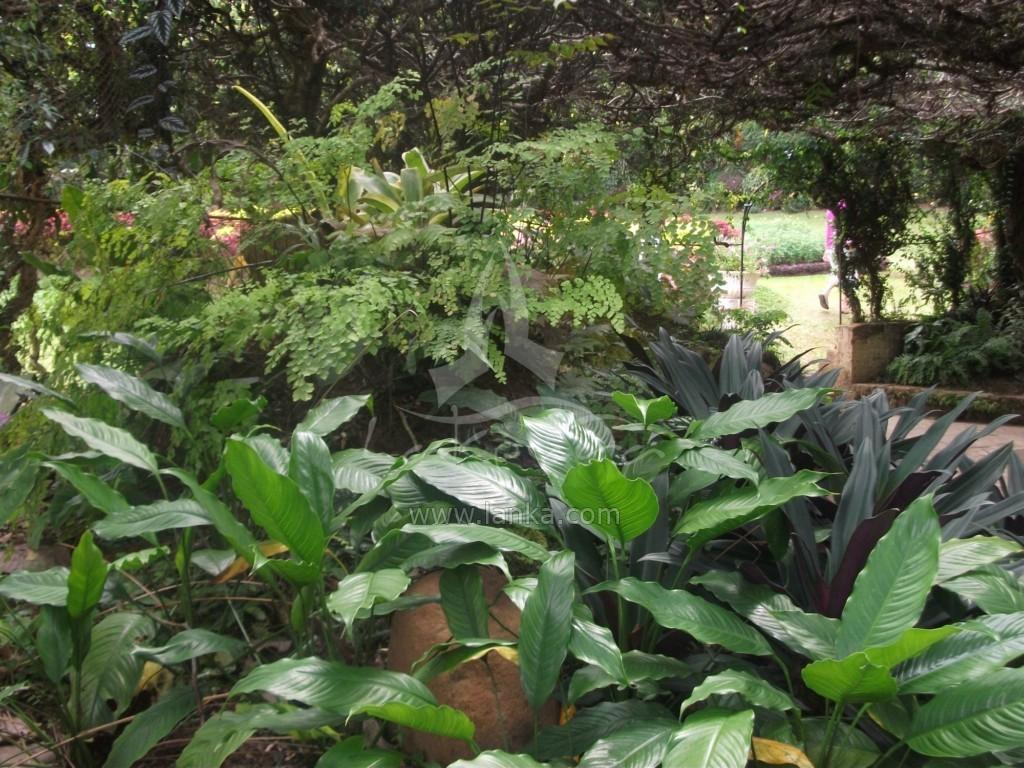What is located in the foreground of the picture? There are plants in the foreground of the picture. What is the person in the image doing? There is a person walking on the grass on the right side of the image. What can be seen in the background of the image? There are trees visible in the background of the image. What type of lamp is being held by the person in the image? There is no lamp present in the image; the person is walking on the grass without any visible objects in their hands. 